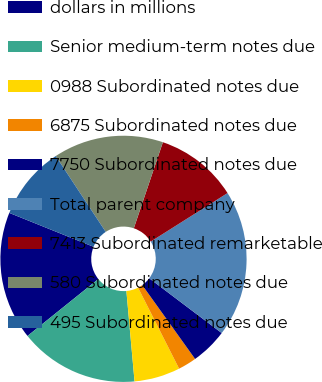Convert chart to OTSL. <chart><loc_0><loc_0><loc_500><loc_500><pie_chart><fcel>dollars in millions<fcel>Senior medium-term notes due<fcel>0988 Subordinated notes due<fcel>6875 Subordinated notes due<fcel>7750 Subordinated notes due<fcel>Total parent company<fcel>7413 Subordinated remarketable<fcel>580 Subordinated notes due<fcel>495 Subordinated notes due<nl><fcel>16.86%<fcel>15.66%<fcel>6.03%<fcel>2.42%<fcel>4.82%<fcel>19.27%<fcel>10.84%<fcel>14.46%<fcel>9.64%<nl></chart> 